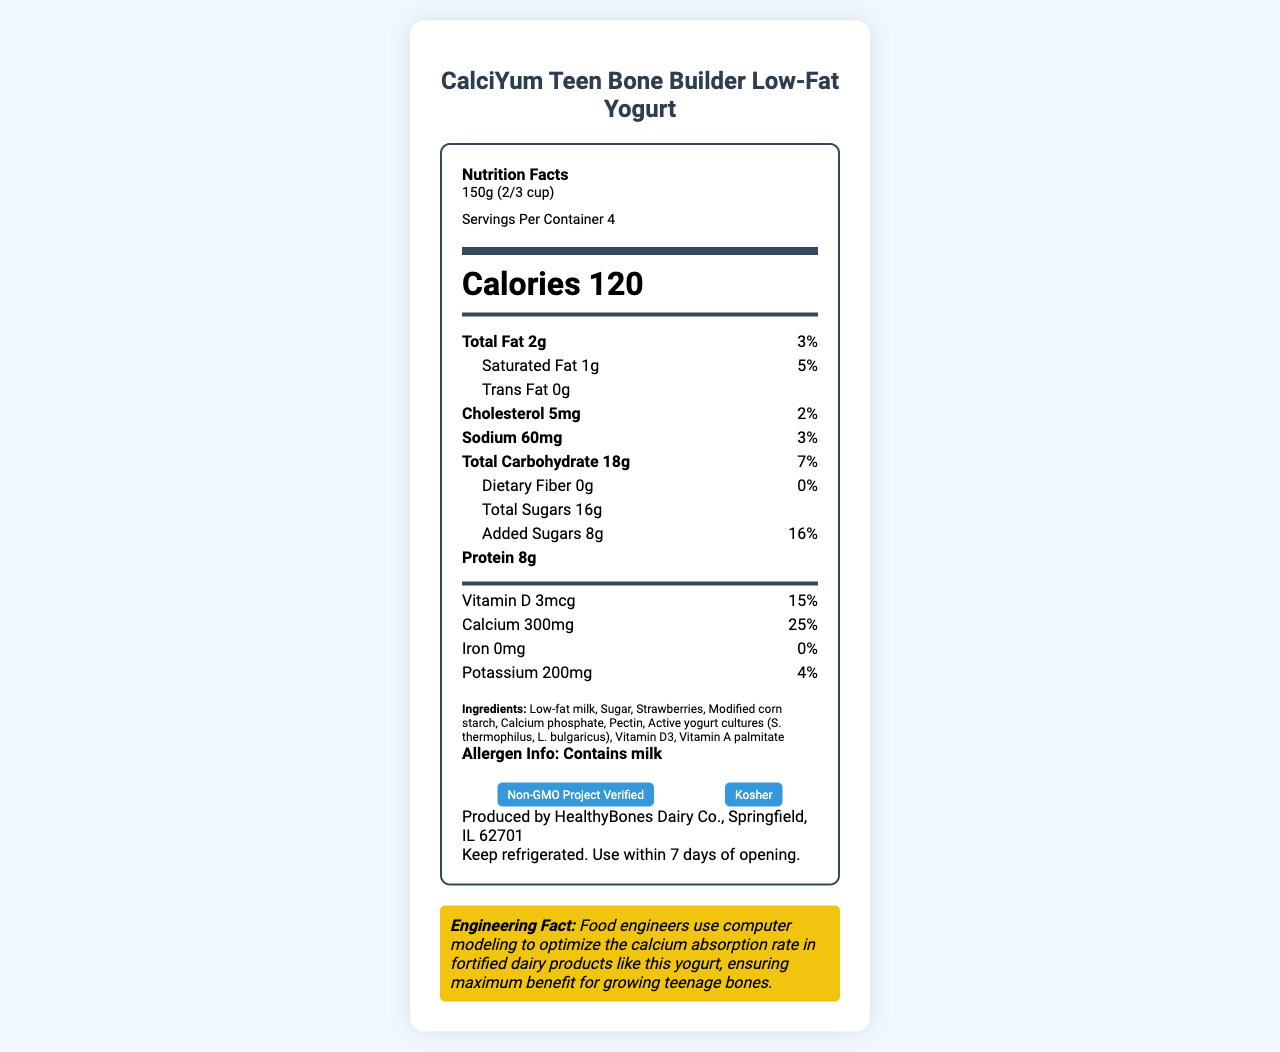what is the serving size of the product? The serving size is listed under the Nutrition Facts header in the document.
Answer: 150g (2/3 cup) how many calories are in one serving? The number of calories per serving is prominently displayed underneath the serving size information.
Answer: 120 calories what is the total fat content per serving? The total fat content per serving is specified in the list of nutrients.
Answer: 2g how much calcium is in one serving? The amount of calcium is listed under the nutrients section with different vitamins and minerals.
Answer: 300mg which ingredient is not listed in the ingredients but could be present based on typical yogurt composition? The document does not provide information beyond the listed ingredients, so we can't determine other possible ingredients.
Answer: I don't know how much protein is in one serving? The protein content per serving is listed in the section detailing various nutrients.
Answer: 8g what is the daily value percentage for added sugars? The daily value percentage for added sugars is shown alongside the amount of added sugars.
Answer: 16% what dietary fiber content does one serving contain? The dietary fiber content per serving is specified in the list of nutrients.
Answer: 0g does the product contain any iron? The document lists iron content as 0mg, indicating that there is no iron in the product.
Answer: No who is the manufacturer of CalciYum Teen Bone Builder Low-Fat Yogurt? The manufacturer's information is provided near the end of the document.
Answer: HealthyBones Dairy Co., Springfield, IL 62701 what certifications does the product have? A. Organic B. Non-GMO C. Kosher D. Gluten-Free The document lists "Non-GMO Project Verified" and "Kosher" as the product’s certifications.
Answer: B. Non-GMO C. Kosher which vitamin has the highest daily value percentage per serving? A. Vitamin A B. Vitamin D C. Calcium D. Magnesium The daily value percentages are listed next to each vitamin, and calcium has the highest at 25%.
Answer: C. Calcium is there any vitamin C in the product? The document lists vitamin C content as 0mg.
Answer: No what is the main idea of this document? The document includes a detailed nutrition facts label, a list of ingredients, allergen information, certifications, storage instructions, and an engineering fact about the product.
Answer: The document provides detailed nutritional information, ingredients, and certifications for CalciYum Teen Bone Builder Low-Fat Yogurt, designed to support bone growth in teenagers. what technical achievement by food engineers is mentioned in the document? The document includes an engineering fact that explains how food engineers enhance the calcium absorption rate in the yogurt.
Answer: Food engineers use computer modeling to optimize the calcium absorption rate in fortified dairy products like this yogurt, ensuring maximum benefit for growing teenage bones. 